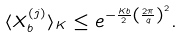Convert formula to latex. <formula><loc_0><loc_0><loc_500><loc_500>\langle X _ { b } ^ { ( j ) } \rangle _ { K } \leq e ^ { - \frac { K b } { 2 } \left ( \frac { 2 \pi } { q } \right ) ^ { 2 } } .</formula> 